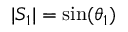<formula> <loc_0><loc_0><loc_500><loc_500>| S _ { 1 } | = \sin ( \theta _ { 1 } )</formula> 